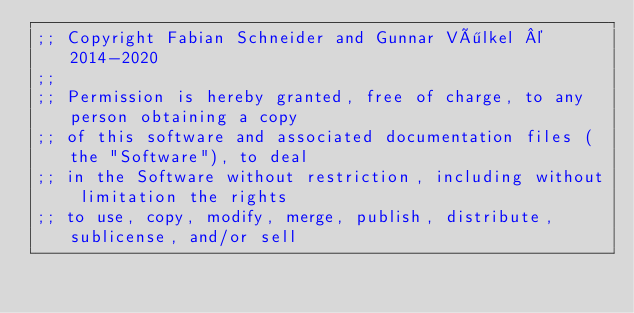<code> <loc_0><loc_0><loc_500><loc_500><_Clojure_>;; Copyright Fabian Schneider and Gunnar Völkel © 2014-2020
;;
;; Permission is hereby granted, free of charge, to any person obtaining a copy
;; of this software and associated documentation files (the "Software"), to deal
;; in the Software without restriction, including without limitation the rights
;; to use, copy, modify, merge, publish, distribute, sublicense, and/or sell</code> 